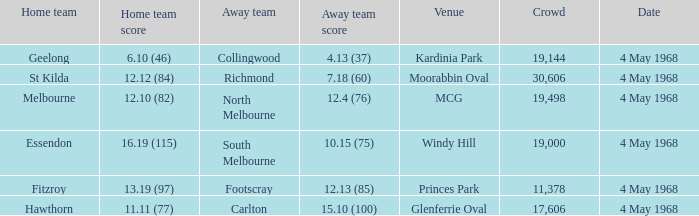What team played at Moorabbin Oval to a crowd of 19,144? St Kilda. 